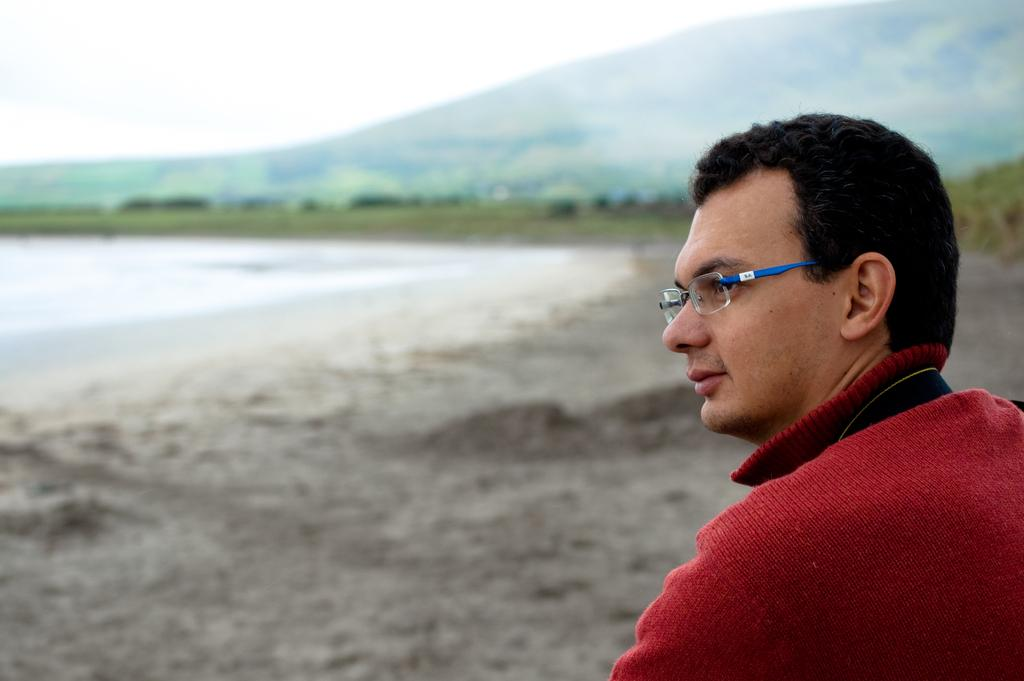What is located on the right side of the image? There is a person on the right side of the image. What can be seen in the image besides the person? Water is visible in the image, and there are trees in the background. How is the background of the image depicted? The background of the image is blurred. What type of ornament is hanging from the person's neck in the image? There is no ornament visible around the person's neck in the image. 